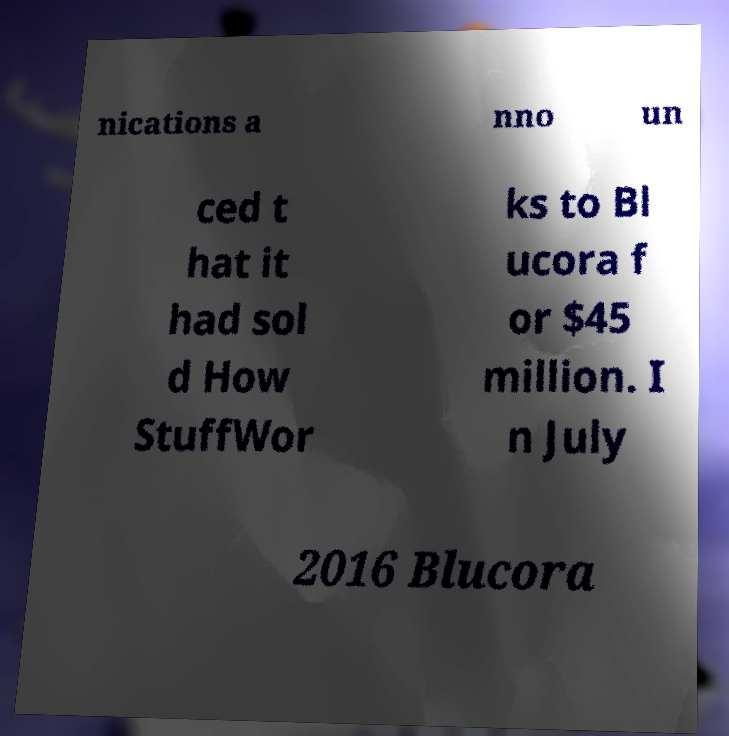There's text embedded in this image that I need extracted. Can you transcribe it verbatim? nications a nno un ced t hat it had sol d How StuffWor ks to Bl ucora f or $45 million. I n July 2016 Blucora 